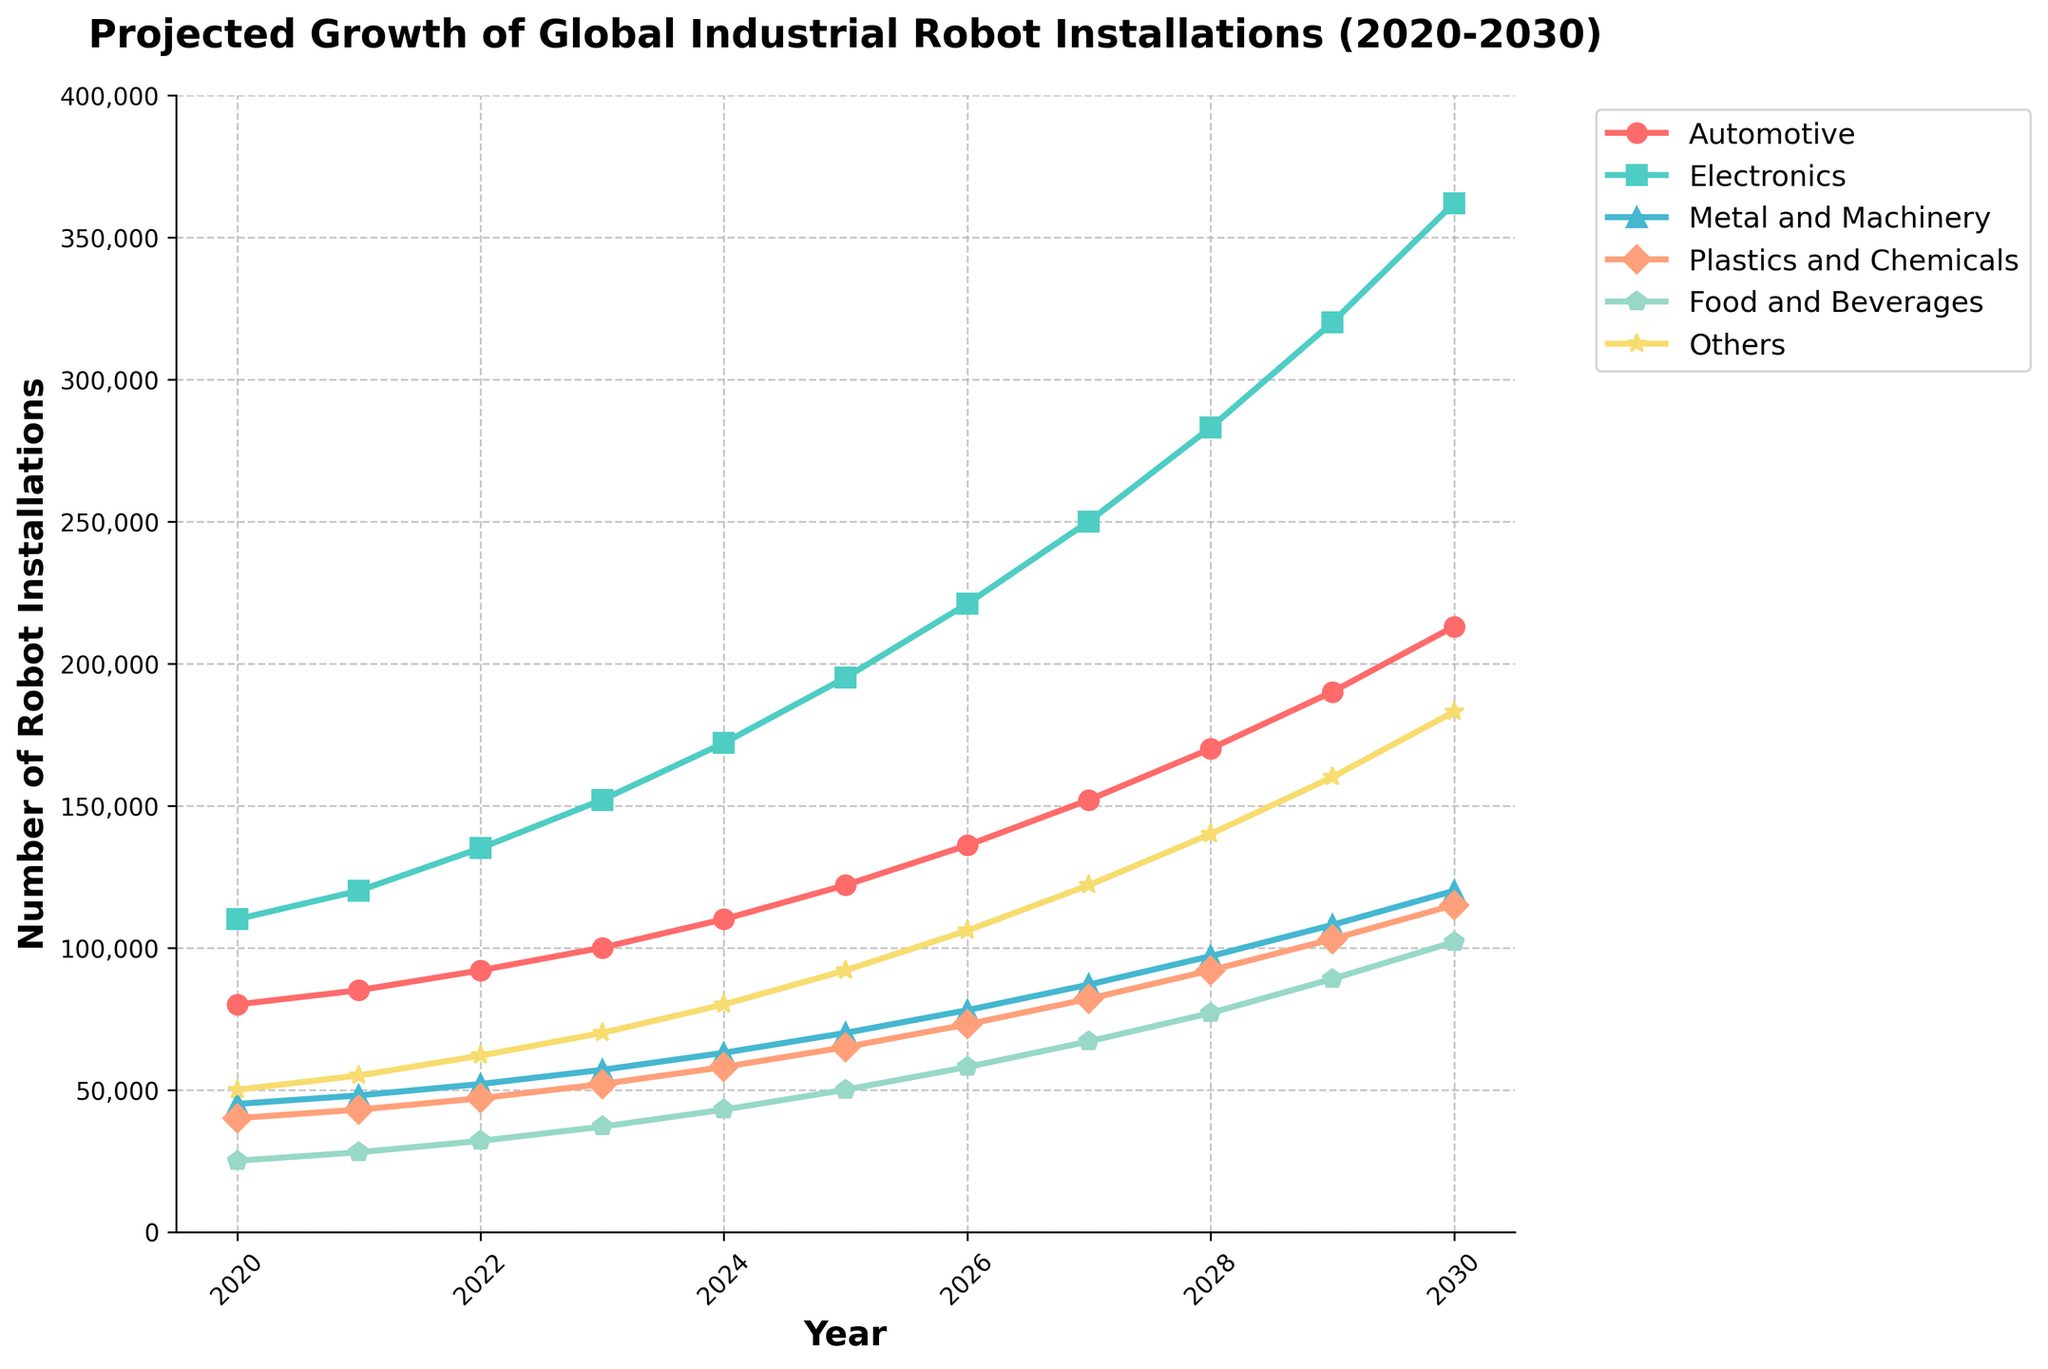What is the trend in robot installations in the Electronics sector from 2020 to 2030? The plot shows a continuous upward trend for the Electronics sector, starting at 110,000 installations in 2020 and rising to 362,000 by 2030.
Answer: Continuous upward trend Between which years does the Automotive sector see the highest increase in robot installations? By visually inspecting the Automotive sector line, the period between 2029 (190,000) and 2030 (213,000) shows the highest increase in installations, with a rise of 23,000.
Answer: 2029 to 2030 How does the number of robot installations in the Food and Beverages sector in 2025 compare to that in the Metal and Machinery sector in 2026? In 2025, the Food and Beverages sector has 50,000 installations, and the Metal and Machinery sector in 2026 has 78,000 installations. Comparatively, the Metal and Machinery sector has more installations.
Answer: Food and Beverages: 50,000, Metal and Machinery: 78,000 What is the average number of robot installations in the Plastics and Chemicals sector from 2020 to 2022? The Plastics and Chemicals installations for 2020, 2021, and 2022 are 40,000, 43,000, and 47,000, respectively. The average is calculated as (40,000 + 43,000 + 47,000) / 3 = 43,333.33.
Answer: 43,333.33 Which sector has the least robot installations in 2023 and what is its value? In 2023, the Food and Beverages sector has the least installations, with a value of 37,000.
Answer: Food and Beverages, 37,000 What is the total number of robot installations in 2027 across all sectors? Adding the installations for 2027: Automotive (152,000) + Electronics (250,000) + Metal and Machinery (87,000) + Plastics and Chemicals (82,000) + Food and Beverages (67,000) + Others (122,000) equals 760,000.
Answer: 760,000 How much more robot installations does the Electronics sector have than the Automotive sector in 2030? In 2030, the Electronics sector has 362,000 installations, while the Automotive sector has 213,000. The difference is 362,000 - 213,000 = 149,000.
Answer: 149,000 Which sector has the steepest incline in robot installations from 2020 to 2030 based on the slope of the line? The Electronics sector has the steepest incline, rising from 110,000 in 2020 to 362,000 in 2030, indicating a significant upward trend.
Answer: Electronics What is the percentage increase in robot installations in the Plastics and Chemicals sector from 2025 to 2026? The installations in 2025 are 65,000 and in 2026 are 73,000. The percentage increase is ((73,000 - 65,000) / 65,000) * 100 ≈ 12.31%.
Answer: 12.31% Compare the robot installations of the 'Others' category between the middle year (2025) and the final year (2030). In 2025, the 'Others' category has 92,000 installations, and in 2030, it has 183,000 installations. Thus, there is a significant increase of 183,000 - 92,000 = 91,000 installations.
Answer: 91,000 increase 